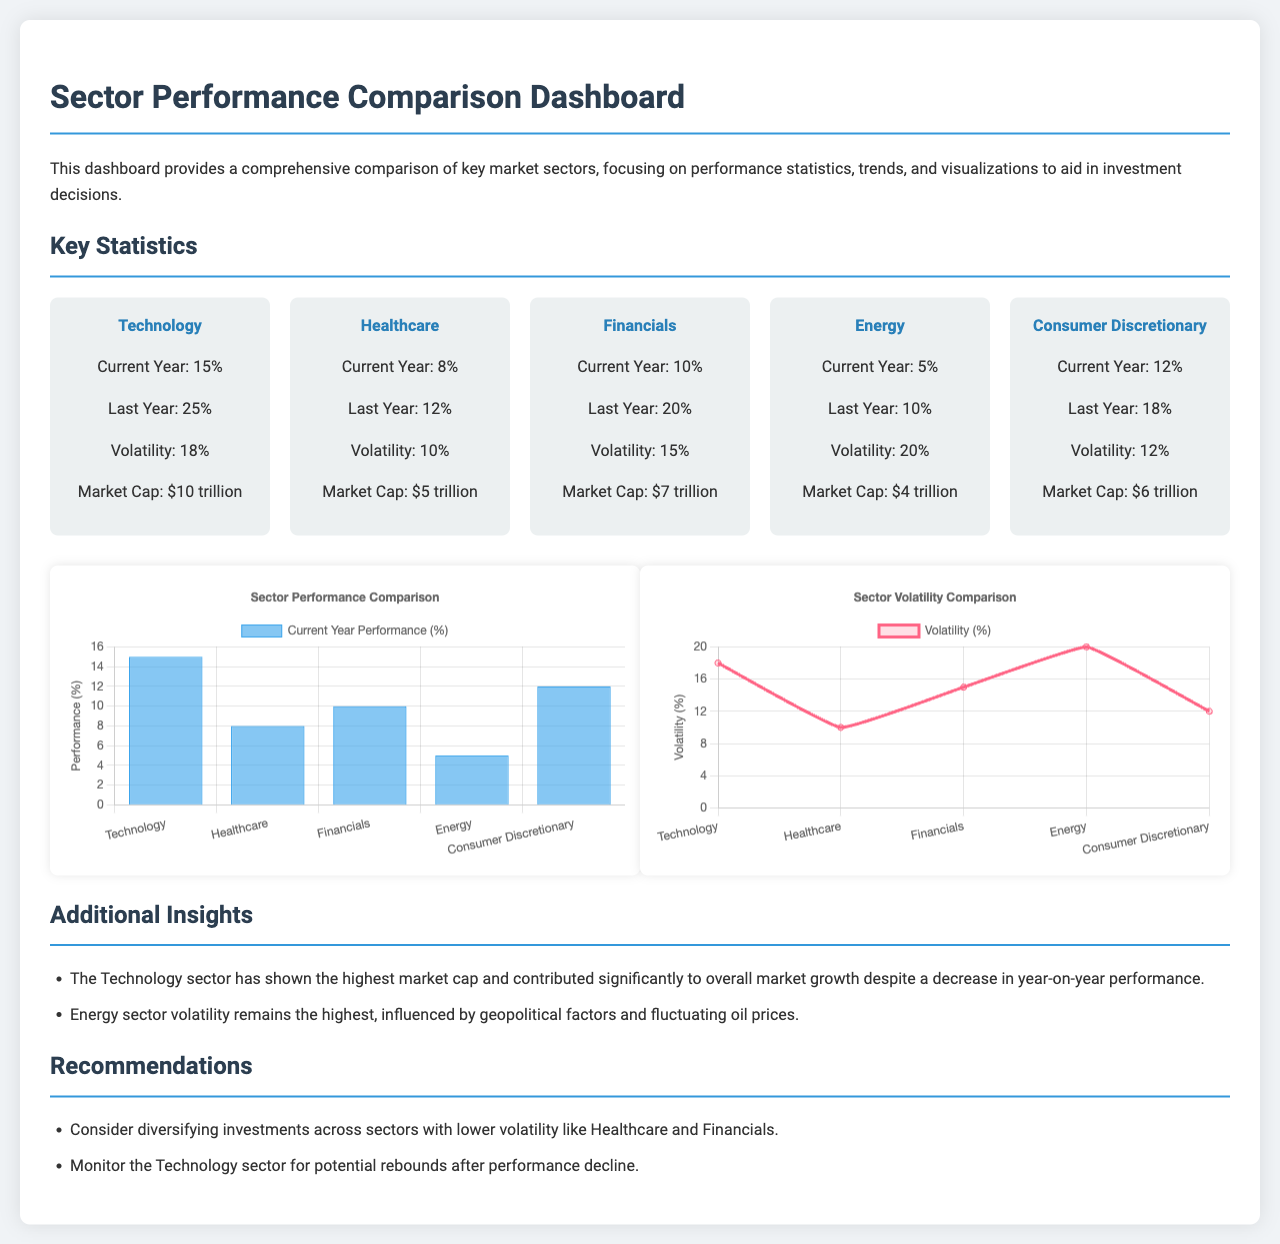What is the performance percentage for the Technology sector this year? The performance percentage for the Technology sector this year is stated directly in the statistics section of the document.
Answer: 15% What is the market capitalization of the Healthcare sector? The market capitalization of the Healthcare sector is provided in the key statistics for that sector.
Answer: $5 trillion Which sector has the highest volatility? The volatility data compares each sector, and the highest volatility is identified in the performance charts and statistics.
Answer: Energy What was the performance percentage for the Financials sector last year? The performance percentage for the Financials sector last year can be found in the key statistics provided in the document.
Answer: 20% According to the additional insights, what has influenced the Energy sector's volatility? The document mentions specific factors that have influenced the Energy sector's volatility in the insights section.
Answer: Geopolitical factors and fluctuating oil prices What recommendation is given for diversifying investments? The recommendations for diversifying investments are listed in the recommendations section of the document.
Answer: Across sectors with lower volatility like Healthcare and Financials What type of chart is used to represent sector performance? The type of chart used to represent sector performance is directly specified in the chart section of the document.
Answer: Bar What does the performance chart visualize? The performance chart visualizes a specific statistical measure, which is mentioned in its title.
Answer: Current Year Performance (%) How many sectors are analyzed in the dashboard? The number of sectors analyzed can be seen as the dashboard lists the sectors in the statistics section.
Answer: Five 